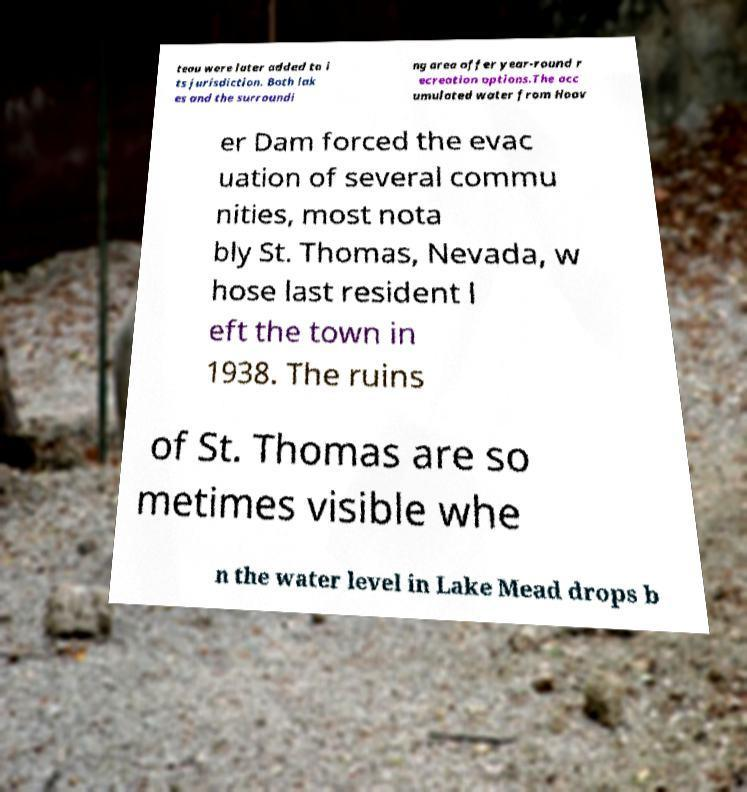There's text embedded in this image that I need extracted. Can you transcribe it verbatim? teau were later added to i ts jurisdiction. Both lak es and the surroundi ng area offer year-round r ecreation options.The acc umulated water from Hoov er Dam forced the evac uation of several commu nities, most nota bly St. Thomas, Nevada, w hose last resident l eft the town in 1938. The ruins of St. Thomas are so metimes visible whe n the water level in Lake Mead drops b 